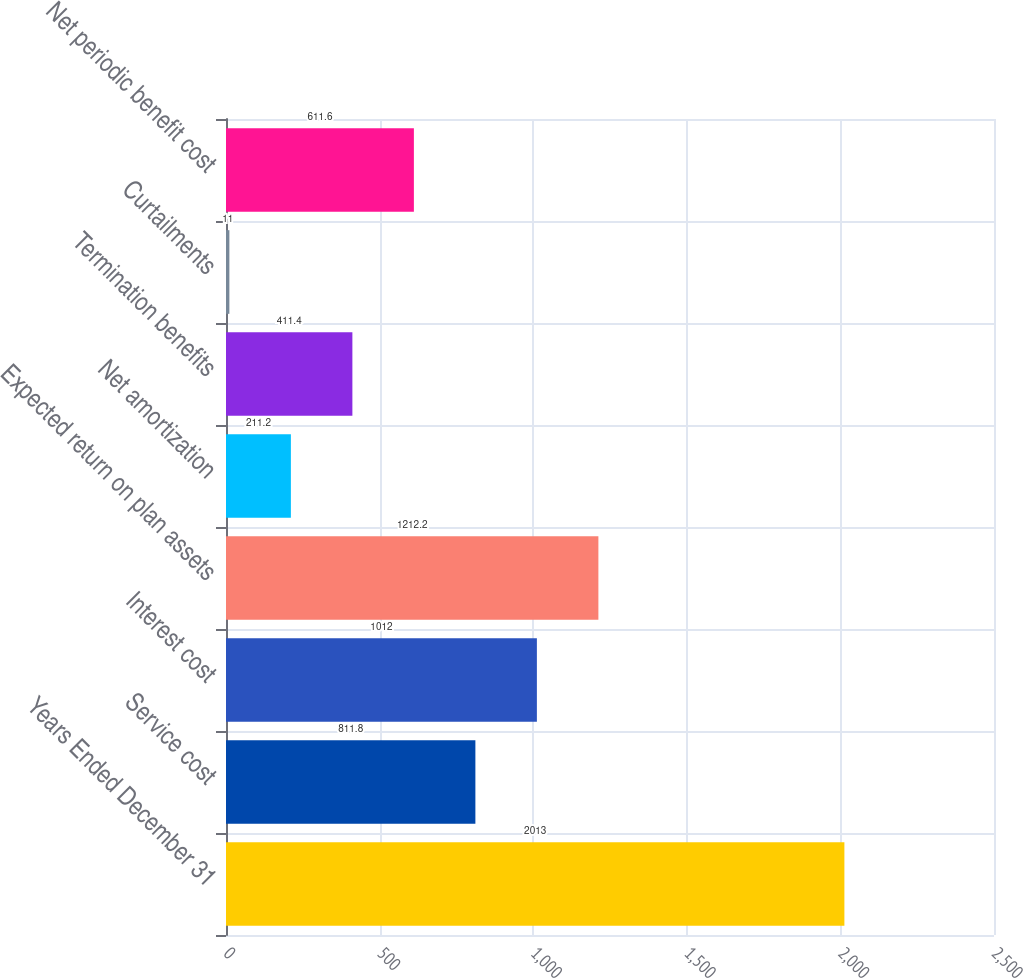Convert chart. <chart><loc_0><loc_0><loc_500><loc_500><bar_chart><fcel>Years Ended December 31<fcel>Service cost<fcel>Interest cost<fcel>Expected return on plan assets<fcel>Net amortization<fcel>Termination benefits<fcel>Curtailments<fcel>Net periodic benefit cost<nl><fcel>2013<fcel>811.8<fcel>1012<fcel>1212.2<fcel>211.2<fcel>411.4<fcel>11<fcel>611.6<nl></chart> 